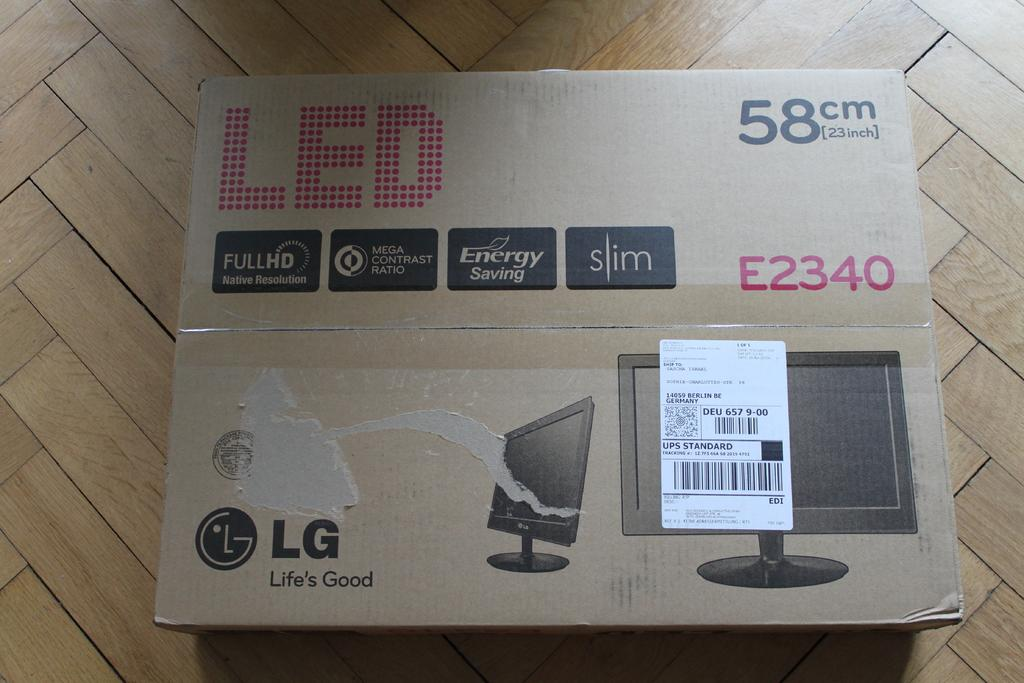What object is present on the wooden surface in the image? There is a cardboard box on the wooden surface in the image. What is the material of the box? The box is made of cardboard. Is there any additional information about the box in the image? Yes, there is a price tag on the cardboard box. How many children are playing with the ants in the morning in the image? There are no children or ants present in the image; it only features a cardboard box on a wooden surface with a price tag. 